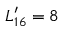<formula> <loc_0><loc_0><loc_500><loc_500>L _ { 1 6 } ^ { \prime } = 8</formula> 